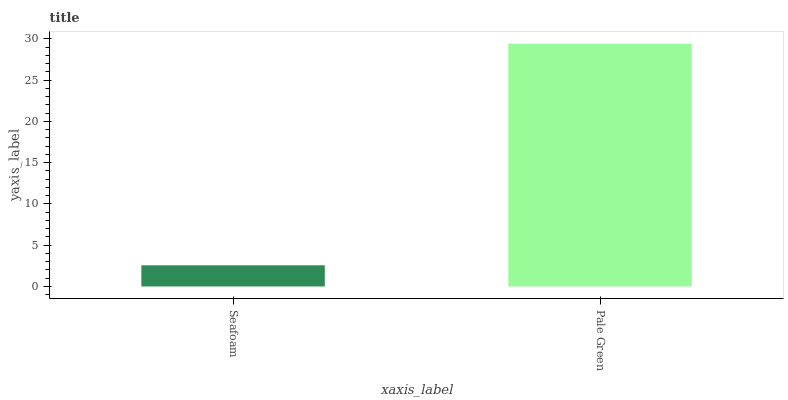Is Seafoam the minimum?
Answer yes or no. Yes. Is Pale Green the maximum?
Answer yes or no. Yes. Is Pale Green the minimum?
Answer yes or no. No. Is Pale Green greater than Seafoam?
Answer yes or no. Yes. Is Seafoam less than Pale Green?
Answer yes or no. Yes. Is Seafoam greater than Pale Green?
Answer yes or no. No. Is Pale Green less than Seafoam?
Answer yes or no. No. Is Pale Green the high median?
Answer yes or no. Yes. Is Seafoam the low median?
Answer yes or no. Yes. Is Seafoam the high median?
Answer yes or no. No. Is Pale Green the low median?
Answer yes or no. No. 